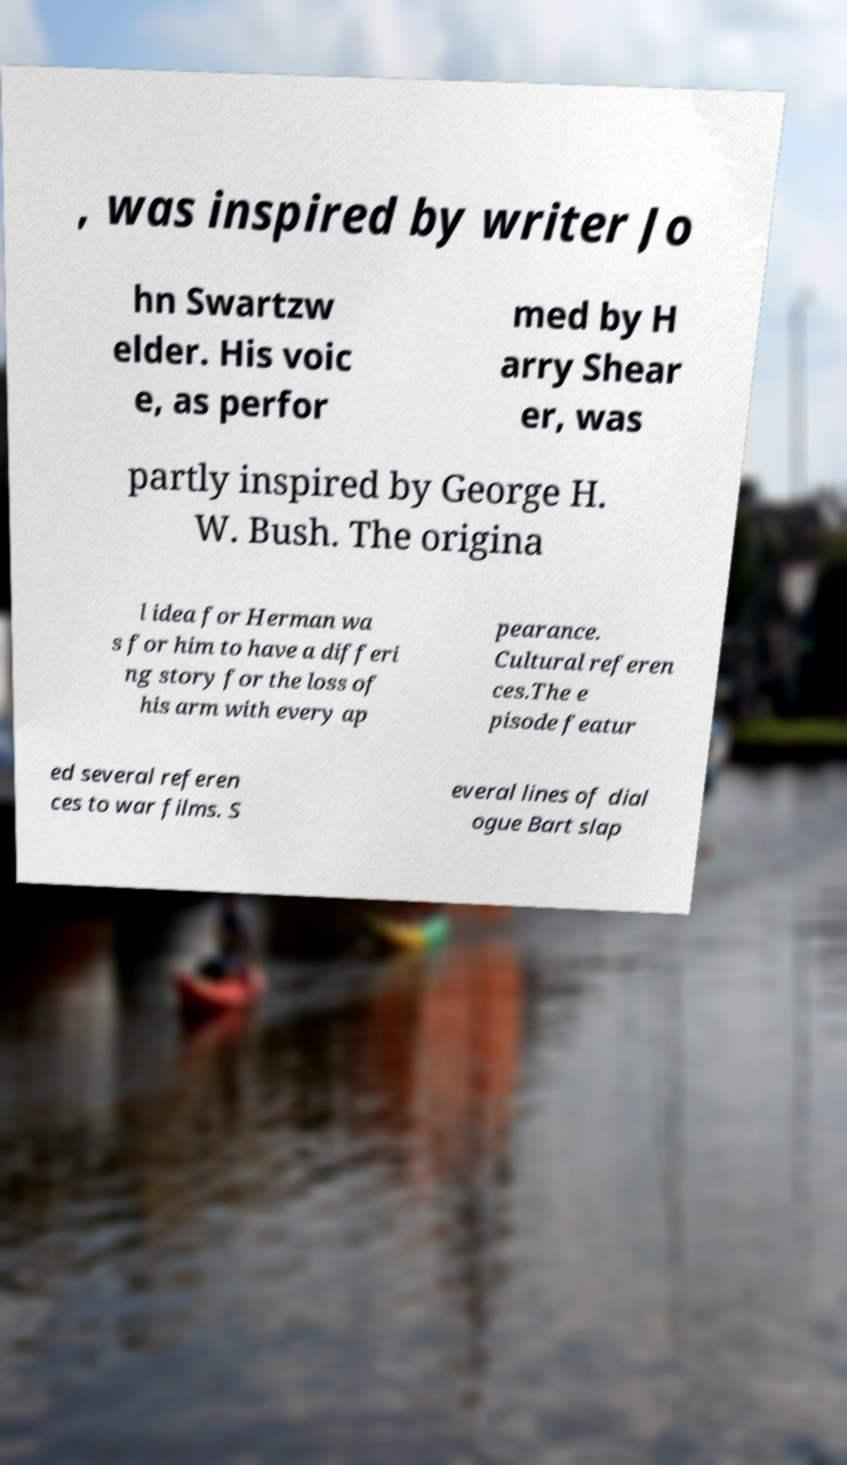There's text embedded in this image that I need extracted. Can you transcribe it verbatim? , was inspired by writer Jo hn Swartzw elder. His voic e, as perfor med by H arry Shear er, was partly inspired by George H. W. Bush. The origina l idea for Herman wa s for him to have a differi ng story for the loss of his arm with every ap pearance. Cultural referen ces.The e pisode featur ed several referen ces to war films. S everal lines of dial ogue Bart slap 